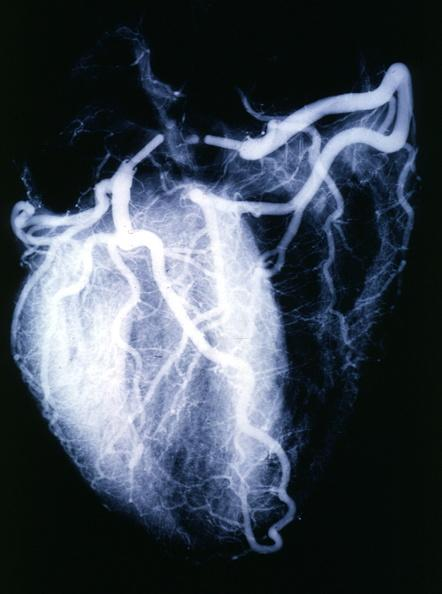s cardiovascular present?
Answer the question using a single word or phrase. Yes 